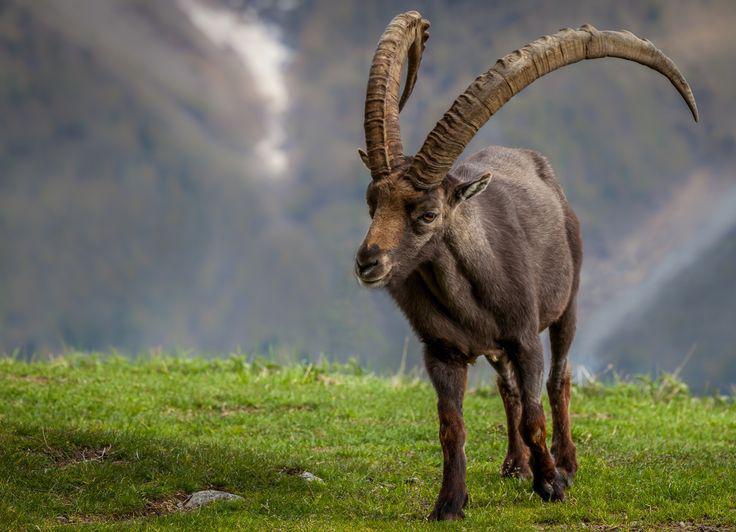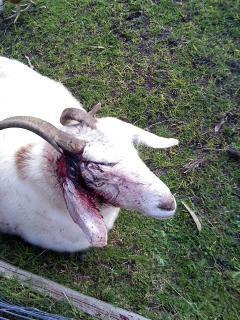The first image is the image on the left, the second image is the image on the right. Given the left and right images, does the statement "The mountain goat in the right image is standing on a steep rocky mountain." hold true? Answer yes or no. No. The first image is the image on the left, the second image is the image on the right. For the images shown, is this caption "An image shows one horned animal standing on dark rocks." true? Answer yes or no. No. 